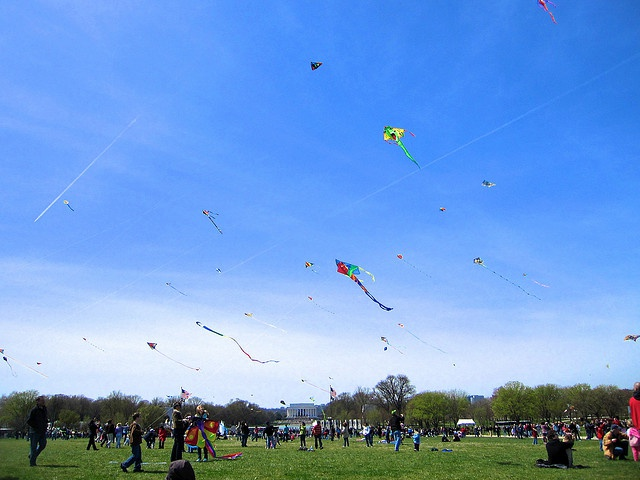Describe the objects in this image and their specific colors. I can see people in lightblue, black, gray, and darkgreen tones, kite in lightblue, lavender, and gray tones, people in lightblue, black, gray, darkgreen, and navy tones, people in lightblue, black, darkgreen, and gray tones, and people in lightblue, black, gray, darkgreen, and darkgray tones in this image. 